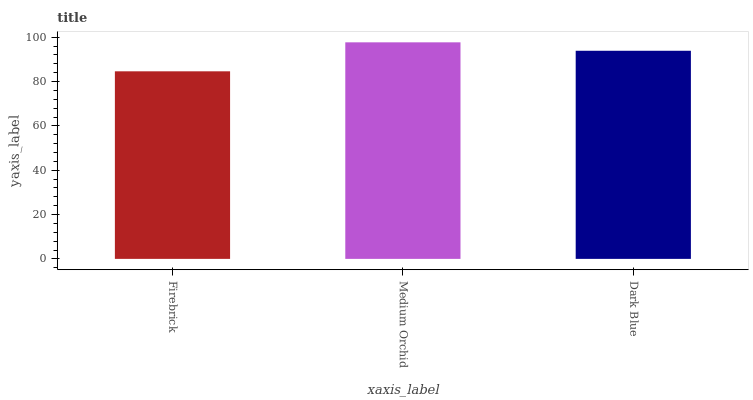Is Firebrick the minimum?
Answer yes or no. Yes. Is Medium Orchid the maximum?
Answer yes or no. Yes. Is Dark Blue the minimum?
Answer yes or no. No. Is Dark Blue the maximum?
Answer yes or no. No. Is Medium Orchid greater than Dark Blue?
Answer yes or no. Yes. Is Dark Blue less than Medium Orchid?
Answer yes or no. Yes. Is Dark Blue greater than Medium Orchid?
Answer yes or no. No. Is Medium Orchid less than Dark Blue?
Answer yes or no. No. Is Dark Blue the high median?
Answer yes or no. Yes. Is Dark Blue the low median?
Answer yes or no. Yes. Is Medium Orchid the high median?
Answer yes or no. No. Is Medium Orchid the low median?
Answer yes or no. No. 